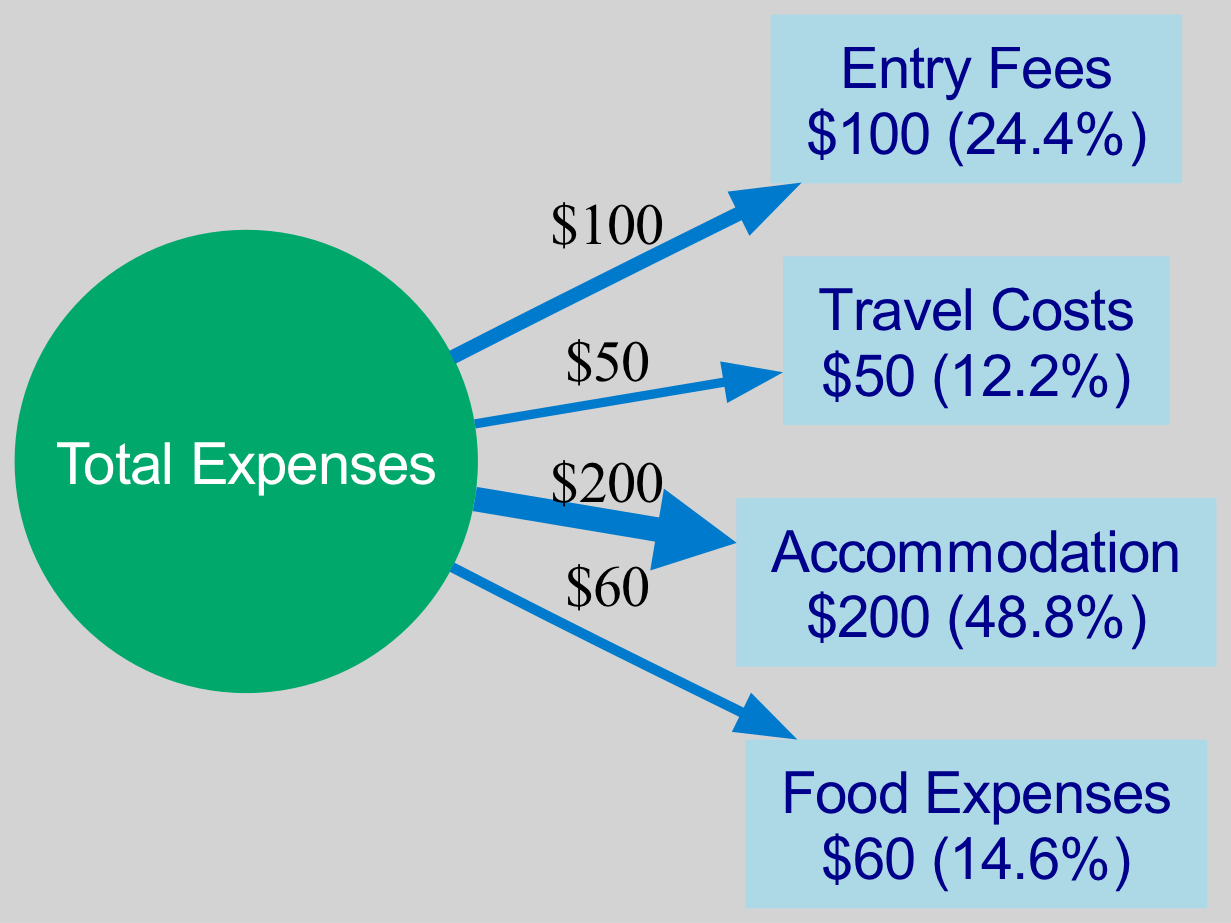What is the total amount of expenses? The diagram shows a central node labeled "Total Expenses." To find the total, one must sum the amounts of all individual expense categories: 100 (Entry Fees) + 50 (Travel Costs) + 200 (Accommodation) + 60 (Food Expenses) = 410.
Answer: 410 Which category has the highest cost? By examining the expense categories' labels on the diagram, it is clear that the accommodation cost is the highest at $200.
Answer: Accommodation What percentage of the total does the travel cost represent? The total expenses amount to $410. To find the percentage of travel costs, divide the travel amount ($50) by the total ($410) and multiply by 100. This results in approximately 12.2%.
Answer: 12.2% How many expense categories are displayed? The diagram has a distinct node for each expense category: Entry Fees, Travel Costs, Accommodation, and Food Expenses. Counting these gives a total of 4 categories.
Answer: 4 What is the amount associated with food expenses? The diagram labels "Food Expenses" and indicates the amount next to it as $60. Therefore, the amount associated with food expenses can be directly read from the diagram.
Answer: 60 Which expense category contributes the lowest percentage to the total? The percentages for each expense category need to be calculated based on the total expenses ($410). The travel costs amount to $50, which has the lowest percentage share at approximately 12.2%, the lowest among all categories.
Answer: Travel Costs What is the relationship between entry fees and total expenses? The diagram shows an edge from "Total Expenses" to "Entry Fees," indicating that entry fees comprise a portion of total expenses. The associated amount for entry fees is $100, visible in the label.
Answer: Comprises a portion Which expense category had exactly half the cost of accommodation? The accommodation cost is $200; half of this is $100. In the diagram, entry fees are labeled as $100, which matches this amount, indicating that entry fees and accommodation have a 2:1 cost ratio.
Answer: Entry Fees 